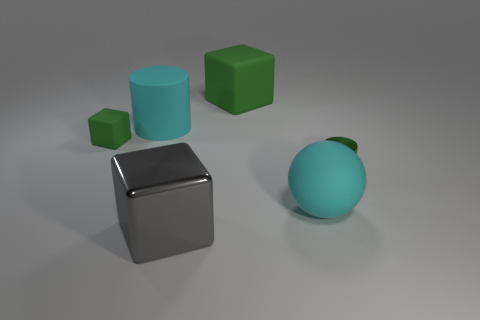How many objects are either cyan cylinders or metallic cylinders to the right of the metal block?
Keep it short and to the point. 2. What number of other objects are there of the same material as the gray thing?
Provide a short and direct response. 1. How many things are green matte things or cyan matte spheres?
Ensure brevity in your answer.  3. Are there more big gray blocks behind the large green thing than cyan matte objects on the left side of the big shiny cube?
Keep it short and to the point. No. There is a small object behind the shiny cylinder; is it the same color as the large block that is behind the metallic cylinder?
Make the answer very short. Yes. There is a cyan thing that is in front of the green block that is on the left side of the green matte block that is on the right side of the small matte object; what size is it?
Your response must be concise. Large. There is a tiny thing that is the same shape as the large green object; what color is it?
Provide a short and direct response. Green. Is the number of green matte blocks right of the shiny cylinder greater than the number of small green shiny cylinders?
Ensure brevity in your answer.  No. Is the shape of the large green matte thing the same as the small green object that is behind the green metal cylinder?
Offer a very short reply. Yes. Is there anything else that has the same size as the cyan cylinder?
Provide a short and direct response. Yes. 